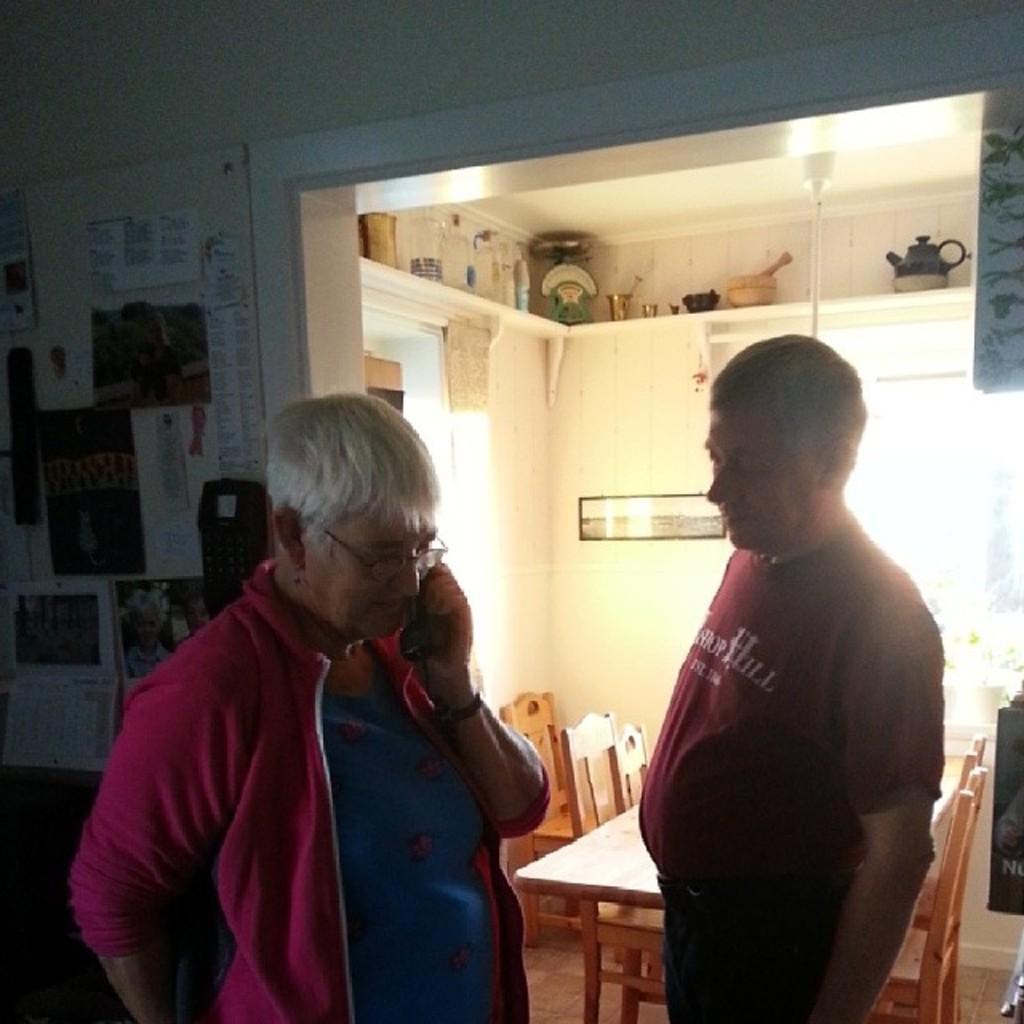Can you describe this image briefly? This picture shows two men standing and a man speaking on the mobile holding in his hand and we see few posters on the wall and couple of chairs and table and few vessels and kettle on the roof 